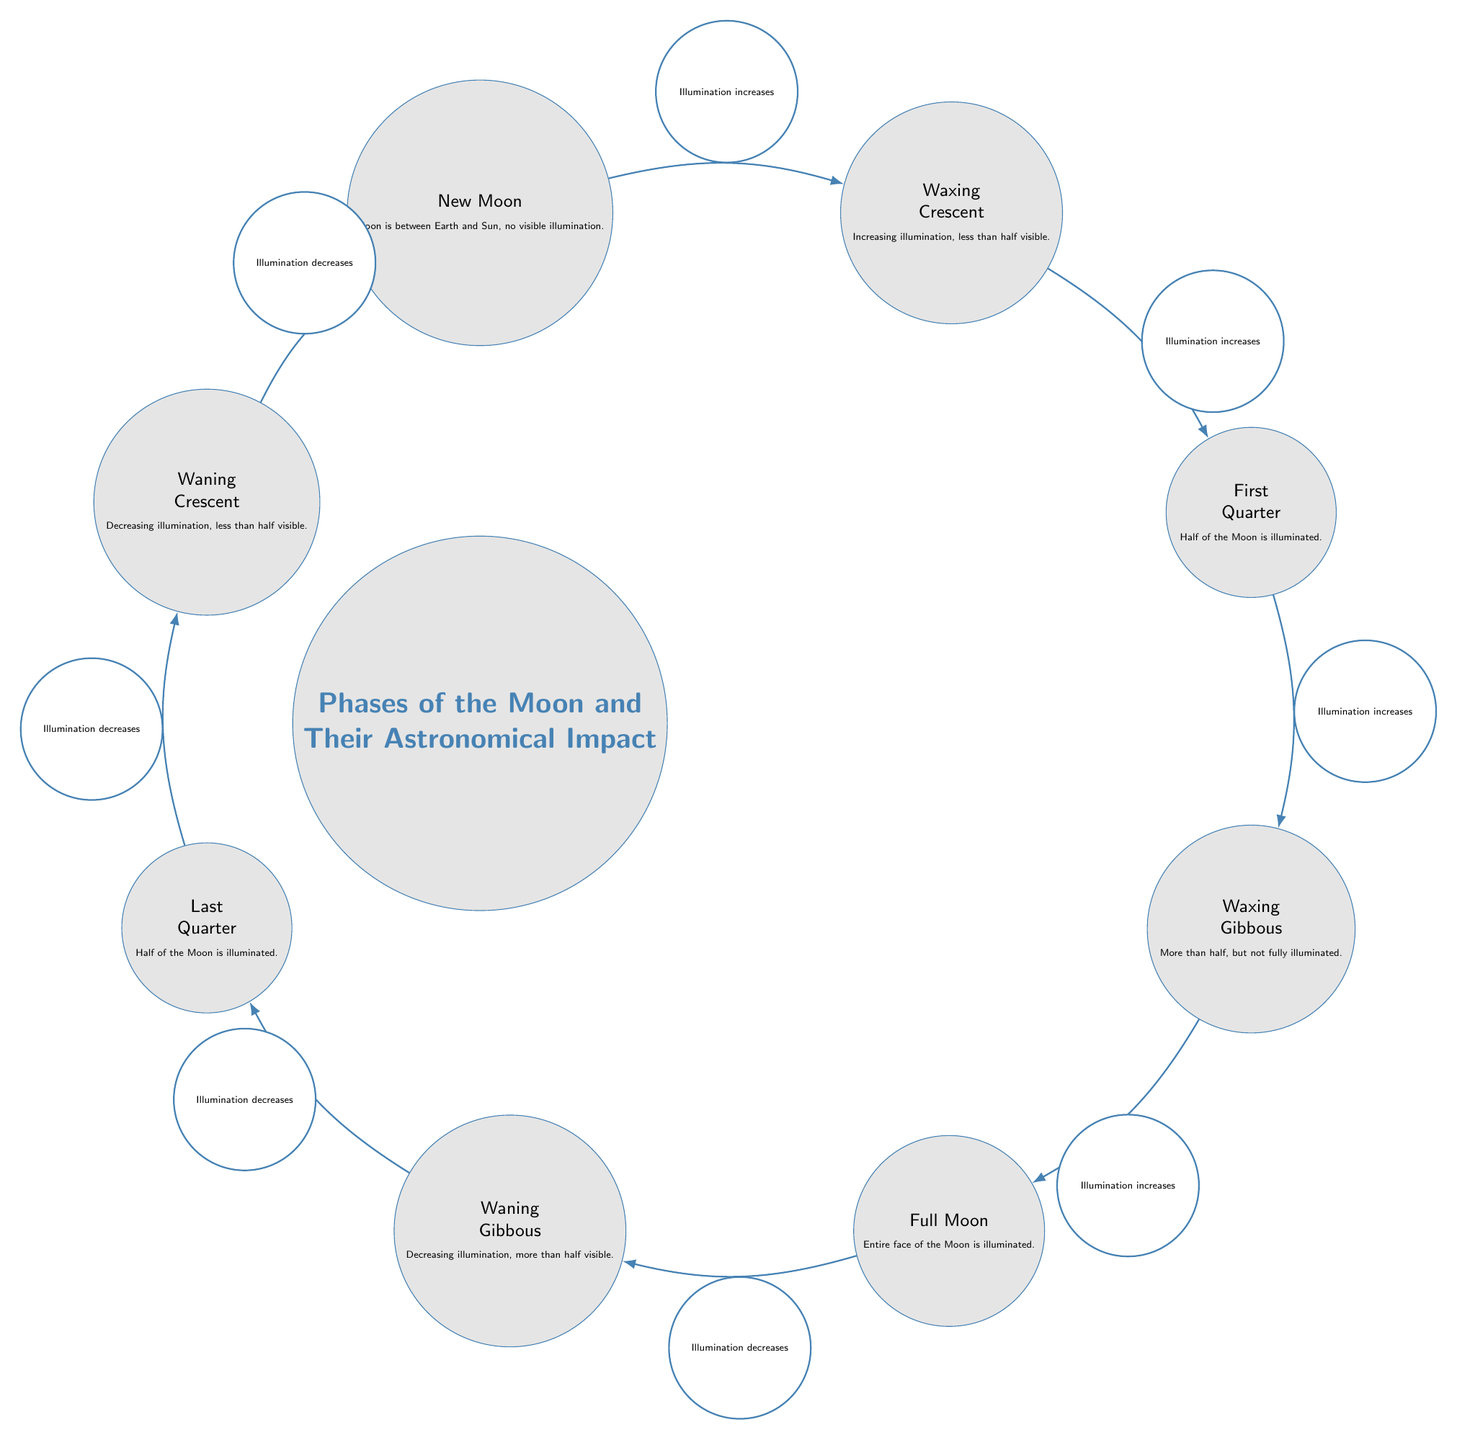What are the eight phases of the Moon shown in the diagram? The diagram features eight phases: New Moon, Waxing Crescent, First Quarter, Waxing Gibbous, Full Moon, Waning Gibbous, Last Quarter, and Waning Crescent.
Answer: New Moon, Waxing Crescent, First Quarter, Waxing Gibbous, Full Moon, Waning Gibbous, Last Quarter, Waning Crescent What phase comes after Waxing Crescent? The diagram indicates a directional flow from one phase to the next. Following Waxing Crescent, the next phase is First Quarter, as shown by the edge connecting them.
Answer: First Quarter Which phase shows half of the Moon illuminated? There are two instances of half illumination in the diagram: First Quarter and Last Quarter. The visual representation indicates that both phases share this characteristic.
Answer: First Quarter, Last Quarter How many edges are there in the diagram? To determine the total number of edges, we count the connections between the phases. There are 7 distinct edges denoting the transitions between phases.
Answer: 7 What is the relationship between Full Moon and Waning Gibbous? The diagram shows that Full Moon is succeeded by Waning Gibbous, with an edge illustrating that illumination decreases from Full Moon to Waning Gibbous.
Answer: Illumination decreases Which phase is at the starting point of the diagram? The diagram begins with the New Moon phase at the top, illustrated as the initial phase before illumination starts increasing.
Answer: New Moon Which phase has an increasing illumination just before it? Upon following the flow of illumination increase, just before the Full Moon phase, the Waxing Gibbous phase is sequentially positioned indicating its increment in brightness.
Answer: Waxing Gibbous Which two phases have more than half of the Moon illuminated? According to the diagram, the Waxing Gibbous and Waning Gibbous phases display more than half of the Moon illuminated, as stated in the descriptions within those nodes.
Answer: Waxing Gibbous, Waning Gibbous How does illumination change from Last Quarter to Waning Crescent? The edge from Last Quarter to Waning Crescent in the diagram indicates a change in illumination that decreases, showing a transition from half illumination to less than half.
Answer: Decreases 